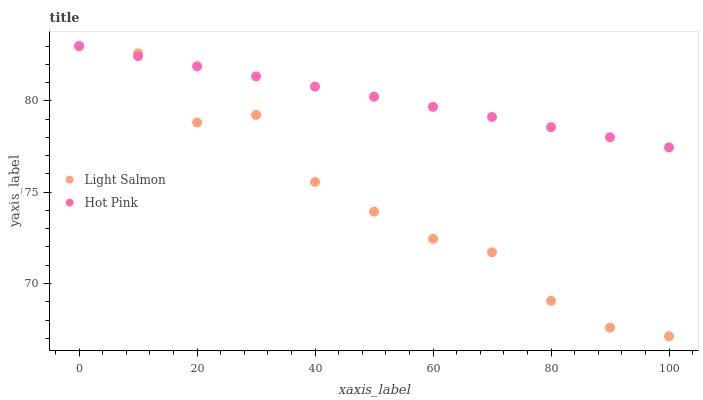Does Light Salmon have the minimum area under the curve?
Answer yes or no. Yes. Does Hot Pink have the maximum area under the curve?
Answer yes or no. Yes. Does Hot Pink have the minimum area under the curve?
Answer yes or no. No. Is Hot Pink the smoothest?
Answer yes or no. Yes. Is Light Salmon the roughest?
Answer yes or no. Yes. Is Hot Pink the roughest?
Answer yes or no. No. Does Light Salmon have the lowest value?
Answer yes or no. Yes. Does Hot Pink have the lowest value?
Answer yes or no. No. Does Hot Pink have the highest value?
Answer yes or no. Yes. Does Hot Pink intersect Light Salmon?
Answer yes or no. Yes. Is Hot Pink less than Light Salmon?
Answer yes or no. No. Is Hot Pink greater than Light Salmon?
Answer yes or no. No. 